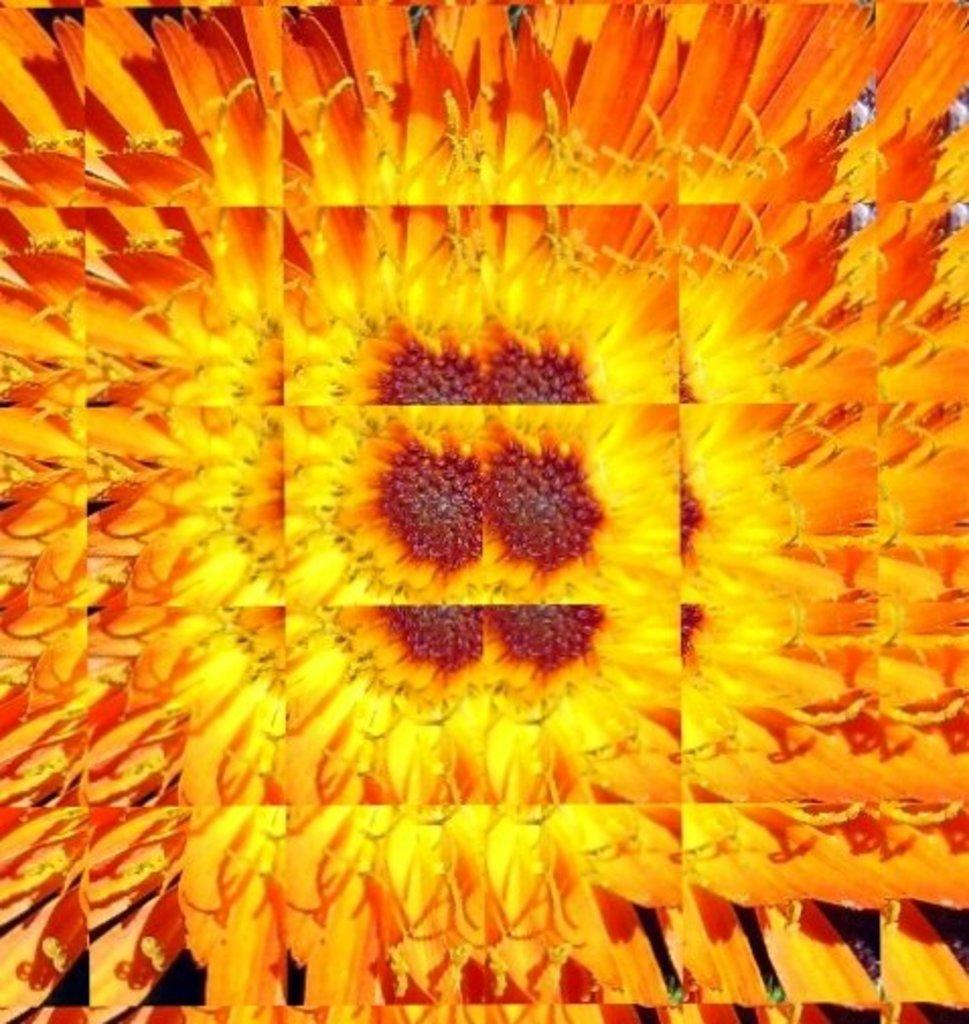What type of image is being described? The image is an edited picture. What can be seen in the edited picture? There are flowers in the image. What type of lace is used to decorate the flowers in the image? There is no lace present in the image; it only features flowers. What type of leather material can be seen in the image? There is no leather material present in the image. 